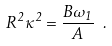<formula> <loc_0><loc_0><loc_500><loc_500>R ^ { 2 } \kappa ^ { 2 } = \frac { B \omega _ { 1 } } { A } \ .</formula> 